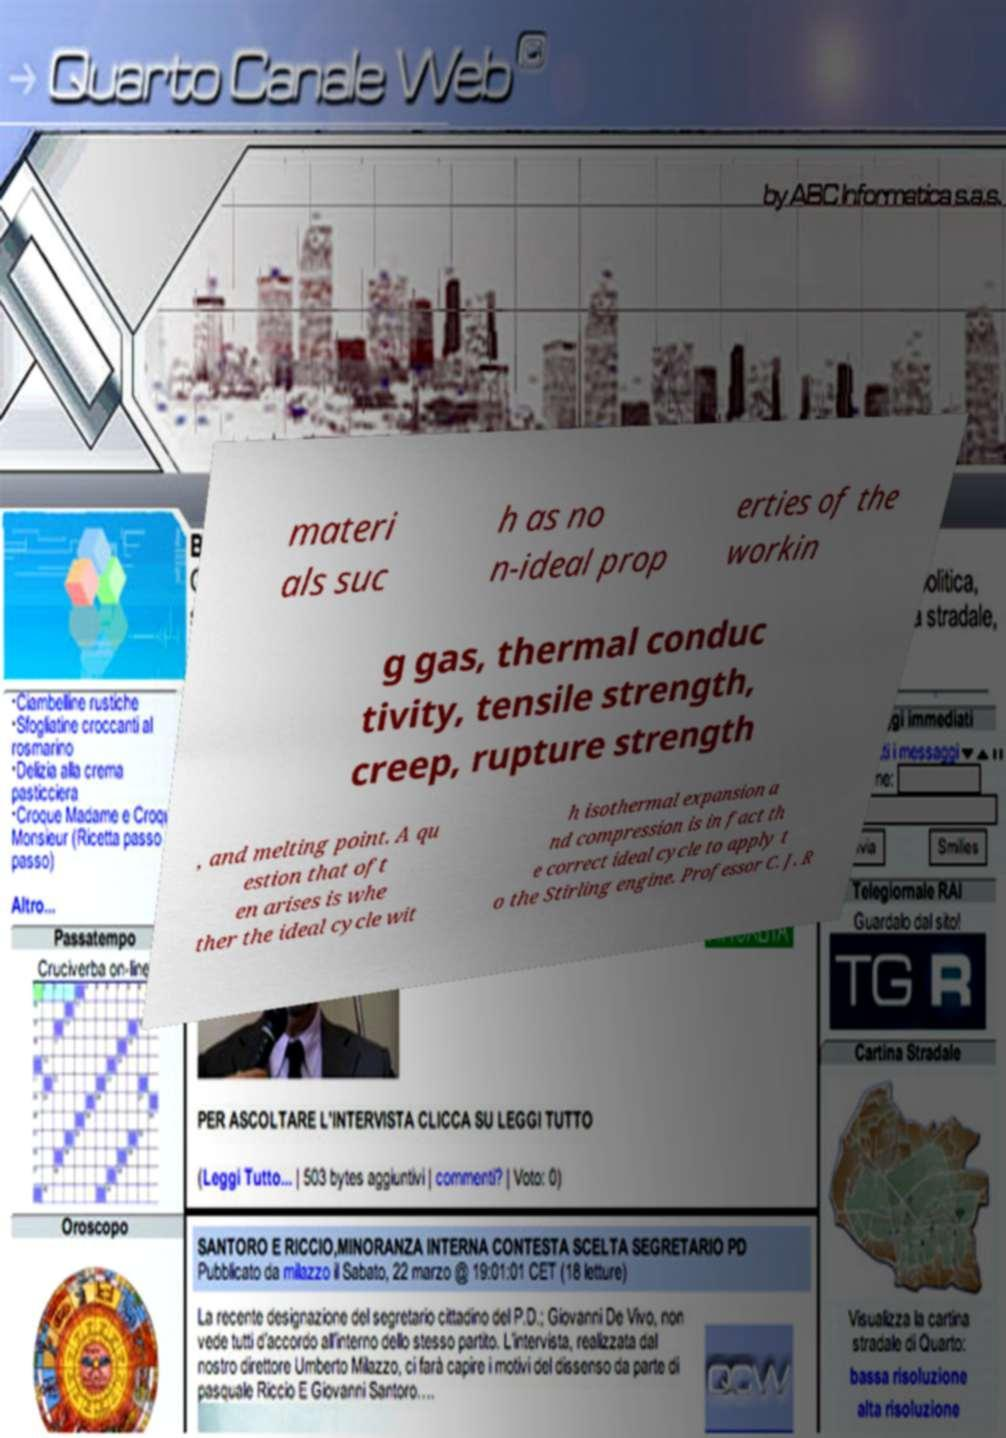Can you read and provide the text displayed in the image?This photo seems to have some interesting text. Can you extract and type it out for me? materi als suc h as no n-ideal prop erties of the workin g gas, thermal conduc tivity, tensile strength, creep, rupture strength , and melting point. A qu estion that oft en arises is whe ther the ideal cycle wit h isothermal expansion a nd compression is in fact th e correct ideal cycle to apply t o the Stirling engine. Professor C. J. R 